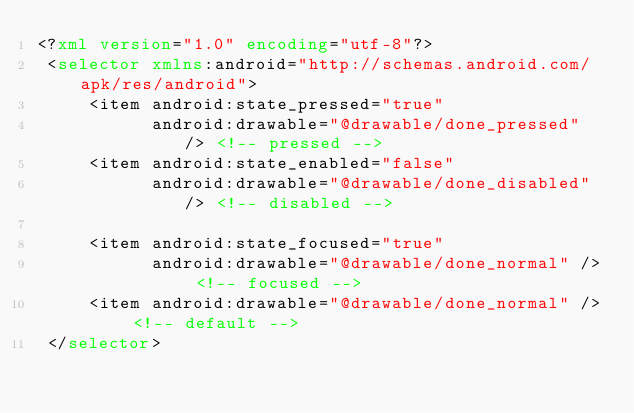<code> <loc_0><loc_0><loc_500><loc_500><_XML_><?xml version="1.0" encoding="utf-8"?>
 <selector xmlns:android="http://schemas.android.com/apk/res/android">
     <item android:state_pressed="true"
           android:drawable="@drawable/done_pressed" /> <!-- pressed -->
     <item android:state_enabled="false"
           android:drawable="@drawable/done_disabled" /> <!-- disabled -->

     <item android:state_focused="true"
           android:drawable="@drawable/done_normal" /> <!-- focused -->
     <item android:drawable="@drawable/done_normal" /> <!-- default -->
 </selector></code> 